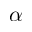Convert formula to latex. <formula><loc_0><loc_0><loc_500><loc_500>\alpha</formula> 